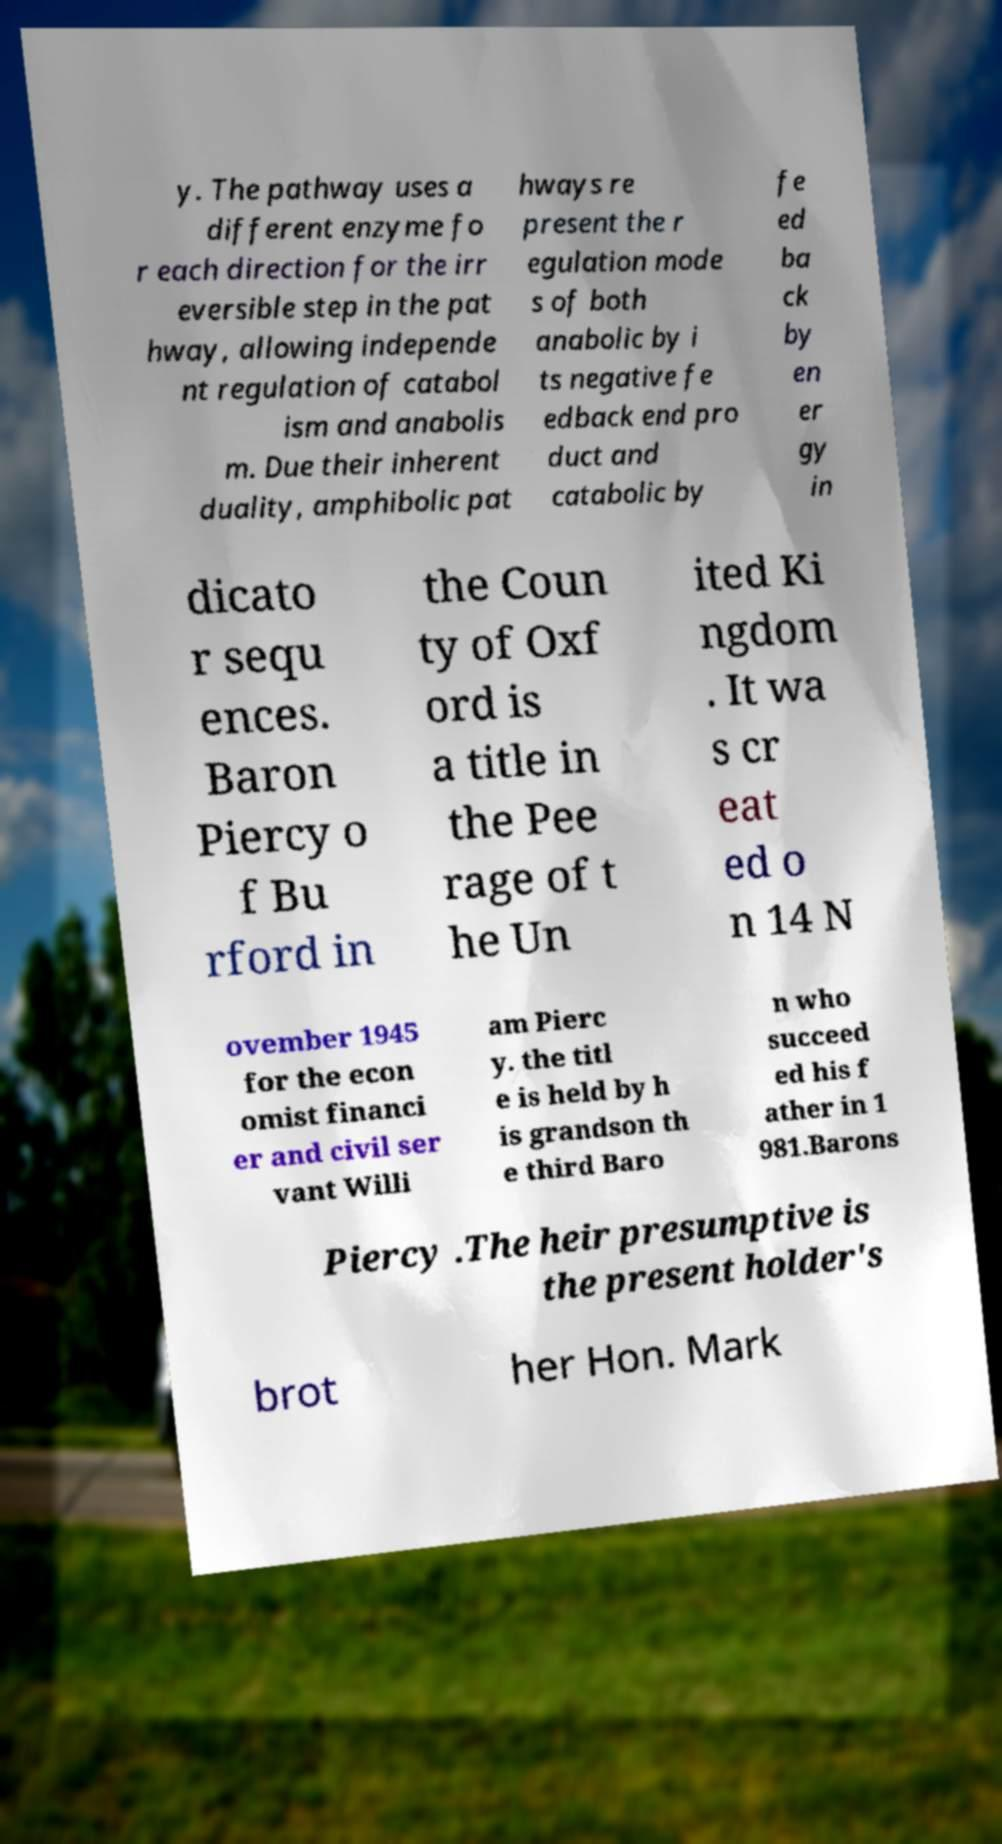For documentation purposes, I need the text within this image transcribed. Could you provide that? y. The pathway uses a different enzyme fo r each direction for the irr eversible step in the pat hway, allowing independe nt regulation of catabol ism and anabolis m. Due their inherent duality, amphibolic pat hways re present the r egulation mode s of both anabolic by i ts negative fe edback end pro duct and catabolic by fe ed ba ck by en er gy in dicato r sequ ences. Baron Piercy o f Bu rford in the Coun ty of Oxf ord is a title in the Pee rage of t he Un ited Ki ngdom . It wa s cr eat ed o n 14 N ovember 1945 for the econ omist financi er and civil ser vant Willi am Pierc y. the titl e is held by h is grandson th e third Baro n who succeed ed his f ather in 1 981.Barons Piercy .The heir presumptive is the present holder's brot her Hon. Mark 